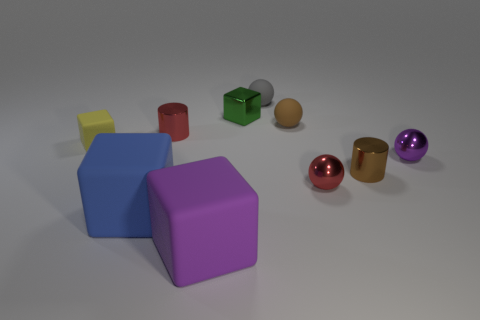Could you guess why these objects have been arranged this way? The arrangement of these objects may be a part of a visual composition experiment. It appears to be an intentional setup potentially for a color study, shape recognition, or a 3D rendering test where lighting and shadow effects on different colors and shapes are observed. 